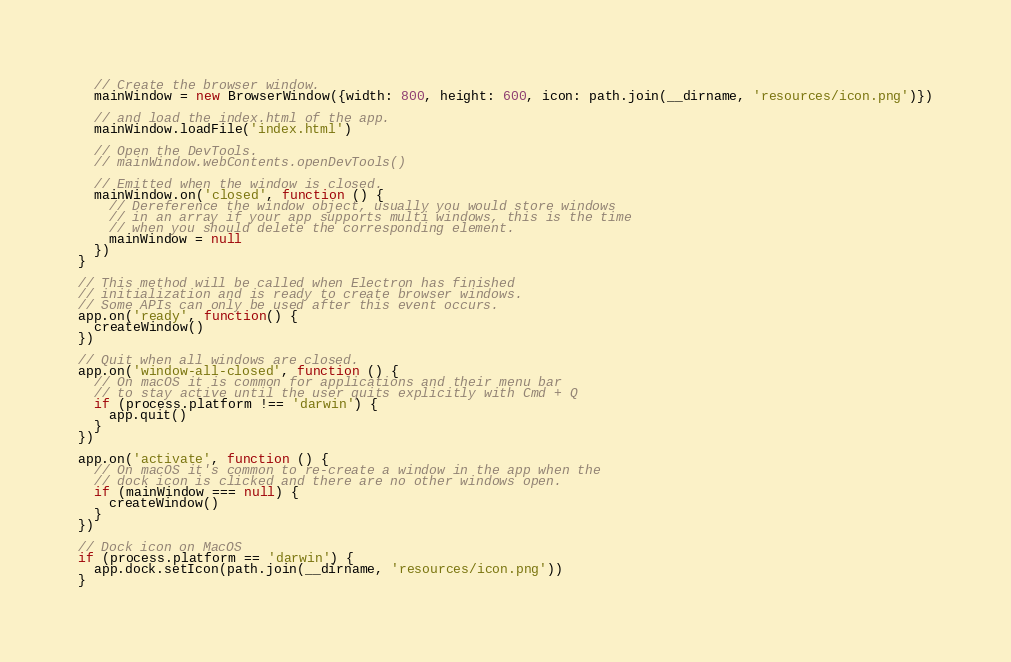<code> <loc_0><loc_0><loc_500><loc_500><_JavaScript_>  // Create the browser window.
  mainWindow = new BrowserWindow({width: 800, height: 600, icon: path.join(__dirname, 'resources/icon.png')})

  // and load the index.html of the app.
  mainWindow.loadFile('index.html')

  // Open the DevTools.
  // mainWindow.webContents.openDevTools()

  // Emitted when the window is closed.
  mainWindow.on('closed', function () {
    // Dereference the window object, usually you would store windows
    // in an array if your app supports multi windows, this is the time
    // when you should delete the corresponding element.
    mainWindow = null
  })
}

// This method will be called when Electron has finished
// initialization and is ready to create browser windows.
// Some APIs can only be used after this event occurs.
app.on('ready', function() {
  createWindow()
})

// Quit when all windows are closed.
app.on('window-all-closed', function () {
  // On macOS it is common for applications and their menu bar
  // to stay active until the user quits explicitly with Cmd + Q
  if (process.platform !== 'darwin') {
    app.quit()
  }
})

app.on('activate', function () {
  // On macOS it's common to re-create a window in the app when the
  // dock icon is clicked and there are no other windows open.
  if (mainWindow === null) {
    createWindow()
  }
})

// Dock icon on MacOS
if (process.platform == 'darwin') {
  app.dock.setIcon(path.join(__dirname, 'resources/icon.png'))
}
</code> 